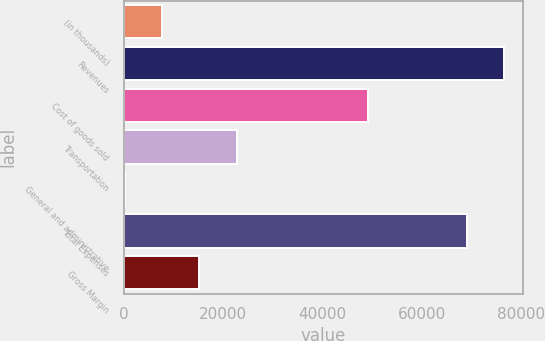Convert chart to OTSL. <chart><loc_0><loc_0><loc_500><loc_500><bar_chart><fcel>(in thousands)<fcel>Revenues<fcel>Cost of goods sold<fcel>Transportation<fcel>General and administrative<fcel>Total Expenses<fcel>Gross Margin<nl><fcel>7734.1<fcel>76664.1<fcel>49191<fcel>22804.3<fcel>199<fcel>69129<fcel>15269.2<nl></chart> 